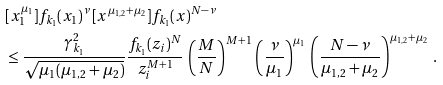<formula> <loc_0><loc_0><loc_500><loc_500>& [ x _ { 1 } ^ { \mu _ { 1 } } ] f _ { k _ { 1 } } ( x _ { 1 } ) ^ { \nu } \, [ x ^ { \mu _ { 1 , 2 } + \mu _ { 2 } } ] f _ { k _ { 1 } } ( x ) ^ { N - \nu } \\ & \leq \frac { \gamma _ { k _ { 1 } } ^ { 2 } } { \sqrt { \mu _ { 1 } ( \mu _ { 1 , 2 } + \mu _ { 2 } ) } } \frac { f _ { k _ { 1 } } ( z _ { i } ) ^ { N } } { z _ { i } ^ { M + 1 } } \, \left ( \frac { M } { N } \right ) ^ { M + 1 } \, \left ( \frac { \nu } { \mu _ { 1 } } \right ) ^ { \mu _ { 1 } } \, \left ( \frac { N - \nu } { \mu _ { 1 , 2 } + \mu _ { 2 } } \right ) ^ { \mu _ { 1 , 2 } + \mu _ { 2 } } \, .</formula> 